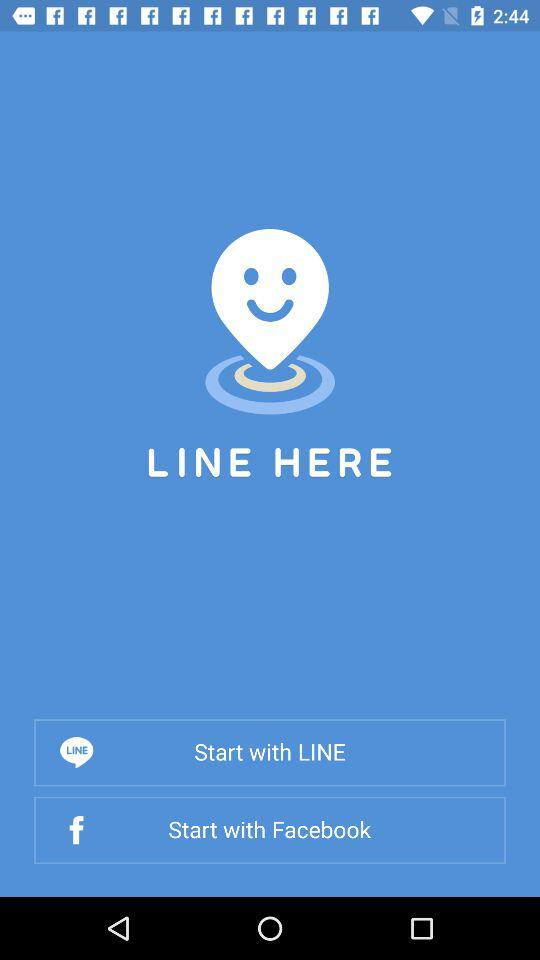What are the names of the applications through which users can start the LINE HERE application? The applications are "LINE" and "Facebook". 